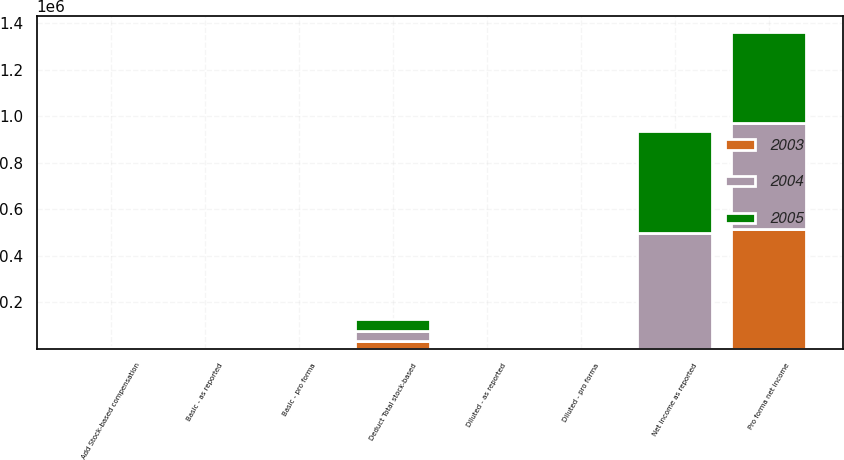Convert chart. <chart><loc_0><loc_0><loc_500><loc_500><stacked_bar_chart><ecel><fcel>Net income as reported<fcel>Add Stock-based compensation<fcel>Deduct Total stock-based<fcel>Pro forma net income<fcel>Basic - as reported<fcel>Basic - pro forma<fcel>Diluted - as reported<fcel>Diluted - pro forma<nl><fcel>2003<fcel>2.71<fcel>2037<fcel>32623<fcel>515691<fcel>2.71<fcel>2.56<fcel>2.66<fcel>2.5<nl><fcel>2004<fcel>499195<fcel>1384<fcel>43710<fcel>456869<fcel>2.45<fcel>2.23<fcel>2.35<fcel>2.13<nl><fcel>2005<fcel>436717<fcel>5297<fcel>52351<fcel>389663<fcel>2.11<fcel>1.88<fcel>2.02<fcel>1.82<nl></chart> 